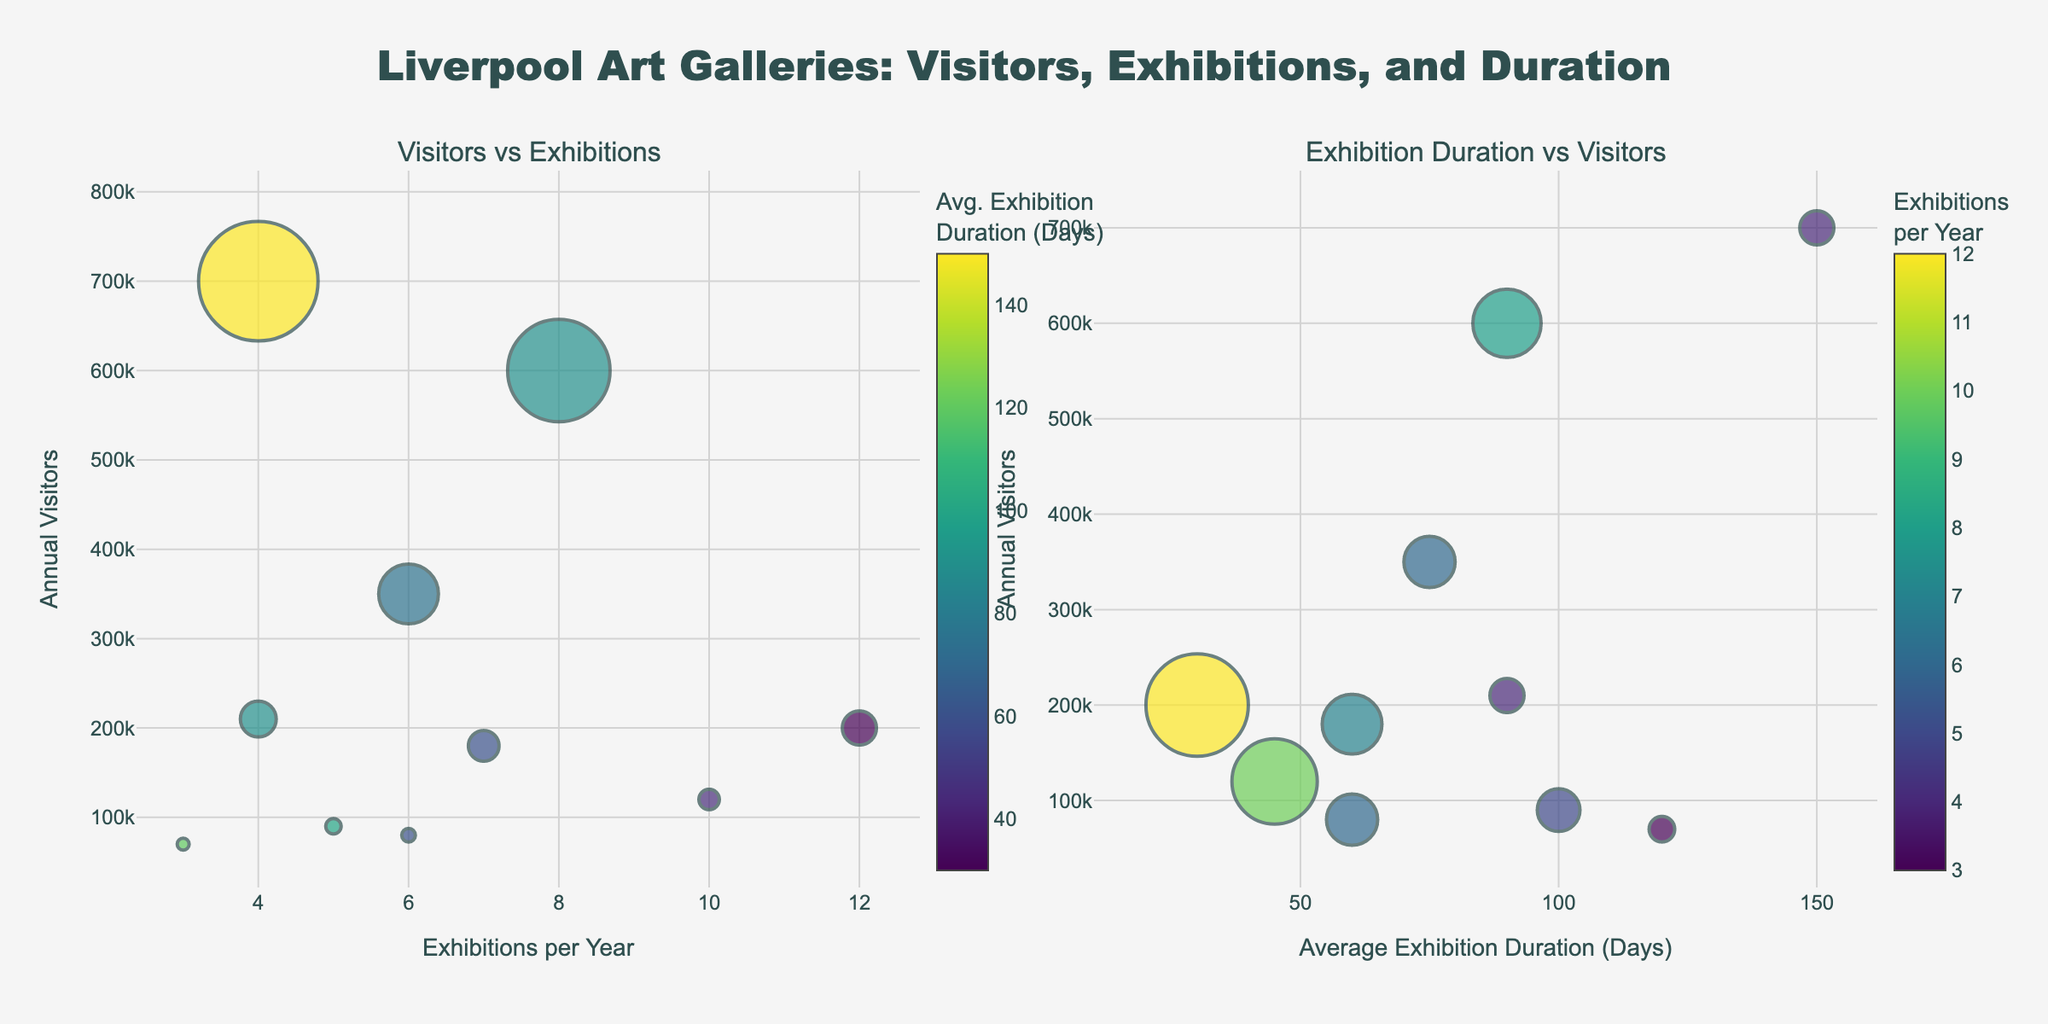How many galleries have their annual visitors mentioned? By counting the number of data points (bubbles) on either subplot, we see there are 10 galleries indicated.
Answer: 10 Which gallery has the highest number of annual visitors? On both subplots, the bubble representing the gallery with the highest annual visitors is labelled "World Museum" with 700,000 visitors.
Answer: World Museum What is the range of exhibitions per year among the galleries? The minimum and maximum values for exhibitions per year are visible from the first subplot. The minimum is 3 (Sudley House) and the maximum is 12 (FACT Liverpool), making the range 12 - 3 = 9.
Answer: 9 Which gallery has the shortest average exhibition duration? Observing the color scaling in the first subplot, the bubble with the darkest color (shortest duration) represents Open Eye Gallery with an average duration of 45 days.
Answer: Open Eye Gallery Are there more galleries with an average exhibition duration above or below 90 days? Counting the number of bubbles with color distribution on the second subplot, you find 4 galleries have durations above and 6 galleries have durations below 90 days.
Answer: Below Which gallery has the highest number of annual visitors but holds relatively few exhibitions per year? The largest bubble in terms of size for visitors but smaller for exhibitions is the World Museum with 4 exhibitions per year.
Answer: World Museum What's the average number of annual visitors for galleries that host more than 6 exhibitions per year? By identifying and averaging the annual visitors for galleries with more than 6 exhibitions per year: Tate Liverpool (600,000), Open Eye Gallery (120,000), FACT Liverpool (200,000), Bluecoat (180,000). Average is (600,000 + 120,000 + 200,000 + 180,000) / 4 = 1,100,000 / 4 = 275,000.
Answer: 275,000 Compare Tate Liverpool and Walker Art Gallery in terms of average exhibition duration and annual visitors. Tate Liverpool has 600,000 visitors and an average duration of 90 days, while Walker Art Gallery has 350,000 visitors and 75 days duration. Tate Liverpool exceeds Walker Art Gallery by 250,000 visitors and has exhibitions that last 15 days longer on average.
Answer: 250,000 visitors more, 15 days longer How many galleries have their color scale representing exhibition frequency in the second subplot fall within the middle of the scale? Middle of the scale corresponds to a color roughly in the middle of the sequential Viridis scale. Looking at the second subplot, except boundary colors, at least 4 galleries (Open Eye Gallery, FACT Liverpool, Bluecoat, Walker Art Gallery) fall into this range.
Answer: 4 